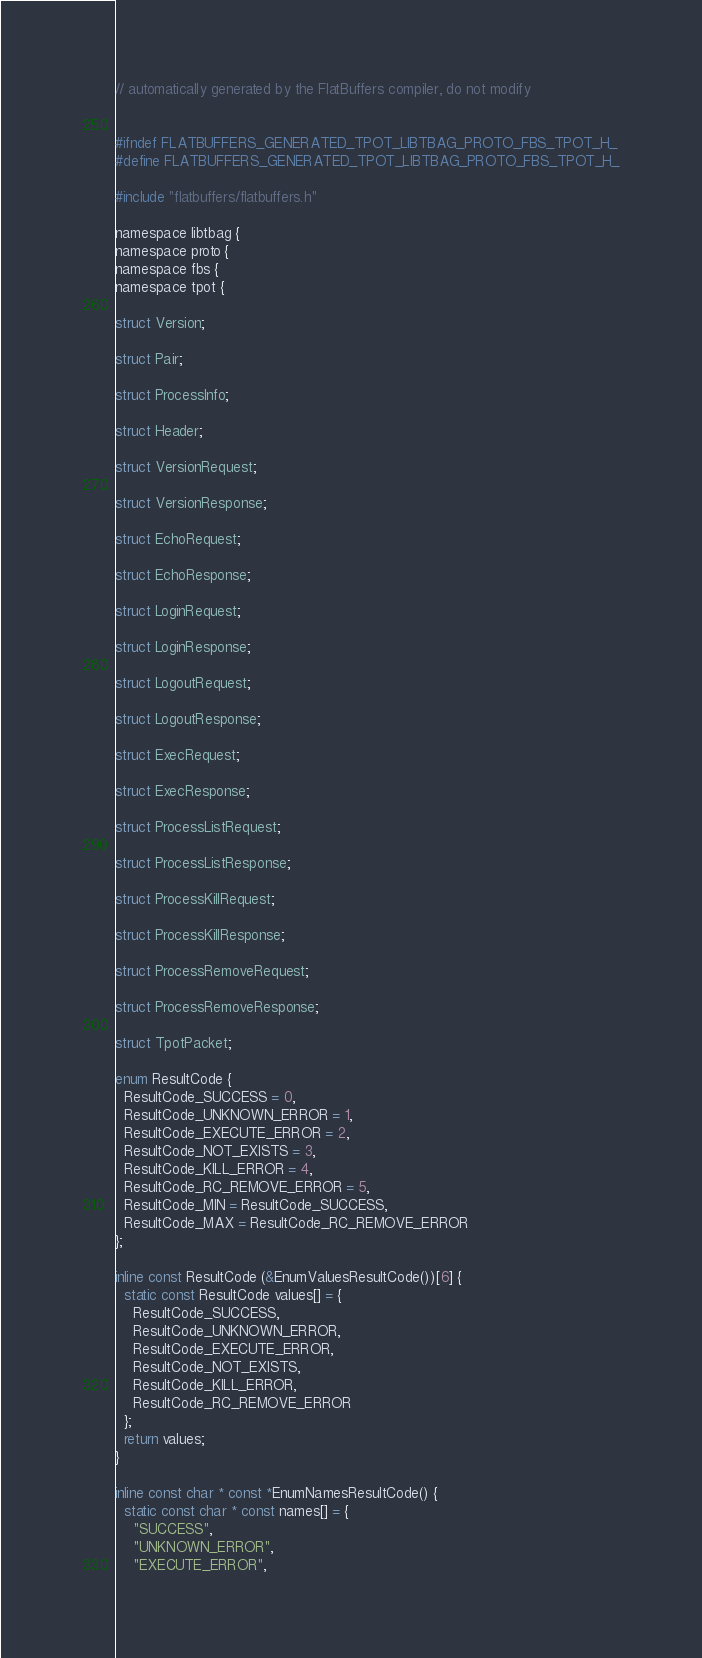<code> <loc_0><loc_0><loc_500><loc_500><_C_>// automatically generated by the FlatBuffers compiler, do not modify


#ifndef FLATBUFFERS_GENERATED_TPOT_LIBTBAG_PROTO_FBS_TPOT_H_
#define FLATBUFFERS_GENERATED_TPOT_LIBTBAG_PROTO_FBS_TPOT_H_

#include "flatbuffers/flatbuffers.h"

namespace libtbag {
namespace proto {
namespace fbs {
namespace tpot {

struct Version;

struct Pair;

struct ProcessInfo;

struct Header;

struct VersionRequest;

struct VersionResponse;

struct EchoRequest;

struct EchoResponse;

struct LoginRequest;

struct LoginResponse;

struct LogoutRequest;

struct LogoutResponse;

struct ExecRequest;

struct ExecResponse;

struct ProcessListRequest;

struct ProcessListResponse;

struct ProcessKillRequest;

struct ProcessKillResponse;

struct ProcessRemoveRequest;

struct ProcessRemoveResponse;

struct TpotPacket;

enum ResultCode {
  ResultCode_SUCCESS = 0,
  ResultCode_UNKNOWN_ERROR = 1,
  ResultCode_EXECUTE_ERROR = 2,
  ResultCode_NOT_EXISTS = 3,
  ResultCode_KILL_ERROR = 4,
  ResultCode_RC_REMOVE_ERROR = 5,
  ResultCode_MIN = ResultCode_SUCCESS,
  ResultCode_MAX = ResultCode_RC_REMOVE_ERROR
};

inline const ResultCode (&EnumValuesResultCode())[6] {
  static const ResultCode values[] = {
    ResultCode_SUCCESS,
    ResultCode_UNKNOWN_ERROR,
    ResultCode_EXECUTE_ERROR,
    ResultCode_NOT_EXISTS,
    ResultCode_KILL_ERROR,
    ResultCode_RC_REMOVE_ERROR
  };
  return values;
}

inline const char * const *EnumNamesResultCode() {
  static const char * const names[] = {
    "SUCCESS",
    "UNKNOWN_ERROR",
    "EXECUTE_ERROR",</code> 